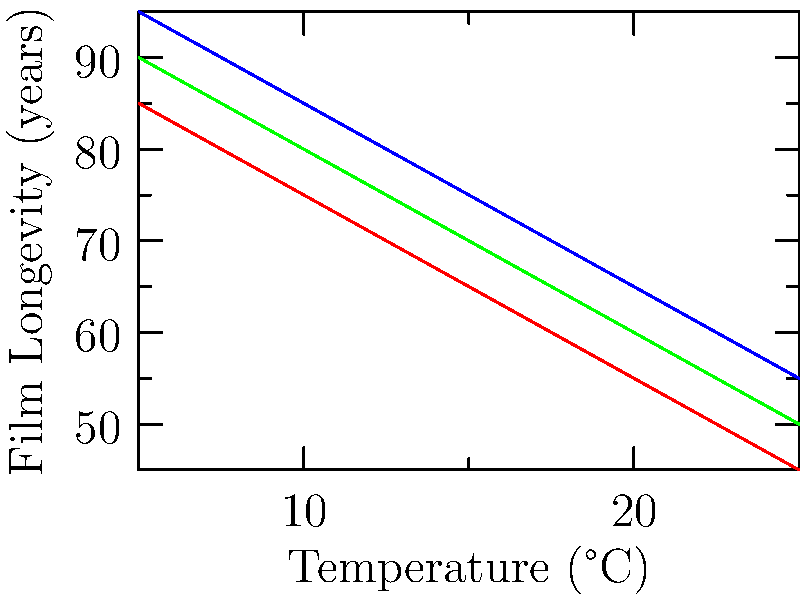Based on the graph showing the impact of different storage conditions on film longevity, what is the estimated difference in longevity between cool storage and warm storage at 20°C? To determine the difference in longevity between cool and warm storage at 20°C, we need to follow these steps:

1. Locate the 20°C point on the x-axis (Temperature).
2. Find the corresponding longevity values for cool storage (blue line) and warm storage (red line) at 20°C.
3. For cool storage at 20°C, the longevity is approximately 65 years.
4. For warm storage at 20°C, the longevity is approximately 55 years.
5. Calculate the difference: 65 years - 55 years = 10 years.

This difference represents the additional years of longevity gained by storing film in cool conditions compared to warm conditions at 20°C.
Answer: 10 years 